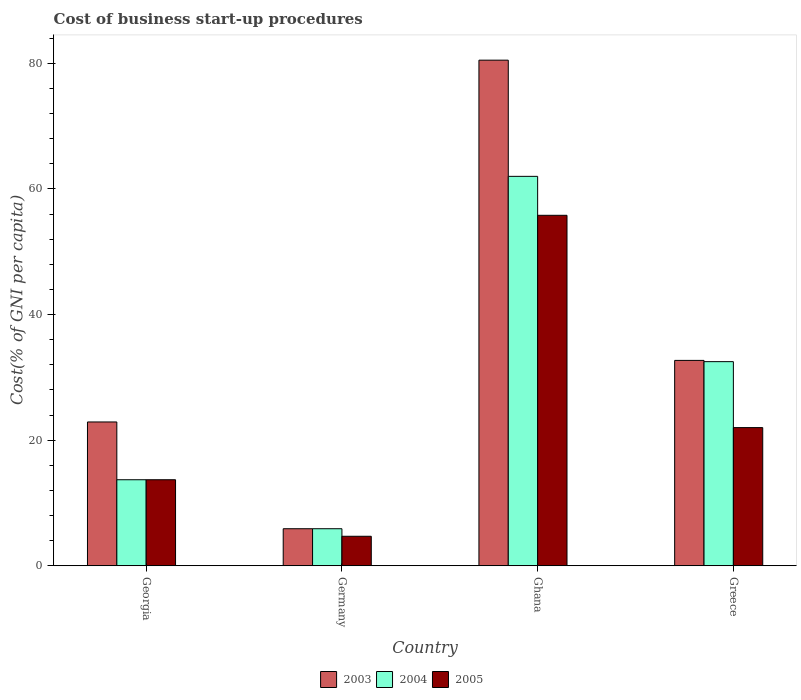How many bars are there on the 4th tick from the right?
Offer a terse response. 3. What is the label of the 3rd group of bars from the left?
Your answer should be compact. Ghana. What is the cost of business start-up procedures in 2003 in Ghana?
Offer a very short reply. 80.5. Across all countries, what is the maximum cost of business start-up procedures in 2005?
Your answer should be very brief. 55.8. Across all countries, what is the minimum cost of business start-up procedures in 2005?
Provide a succinct answer. 4.7. In which country was the cost of business start-up procedures in 2003 maximum?
Your answer should be compact. Ghana. What is the total cost of business start-up procedures in 2005 in the graph?
Make the answer very short. 96.2. What is the difference between the cost of business start-up procedures in 2004 in Germany and that in Greece?
Your answer should be compact. -26.6. What is the difference between the cost of business start-up procedures in 2004 in Georgia and the cost of business start-up procedures in 2003 in Germany?
Keep it short and to the point. 7.8. What is the average cost of business start-up procedures in 2003 per country?
Give a very brief answer. 35.5. What is the difference between the cost of business start-up procedures of/in 2004 and cost of business start-up procedures of/in 2003 in Germany?
Provide a succinct answer. 0. What is the ratio of the cost of business start-up procedures in 2005 in Ghana to that in Greece?
Provide a succinct answer. 2.54. Is the cost of business start-up procedures in 2004 in Georgia less than that in Greece?
Your answer should be very brief. Yes. What is the difference between the highest and the lowest cost of business start-up procedures in 2003?
Your answer should be compact. 74.6. In how many countries, is the cost of business start-up procedures in 2003 greater than the average cost of business start-up procedures in 2003 taken over all countries?
Make the answer very short. 1. Are all the bars in the graph horizontal?
Offer a very short reply. No. What is the difference between two consecutive major ticks on the Y-axis?
Your answer should be very brief. 20. Are the values on the major ticks of Y-axis written in scientific E-notation?
Provide a succinct answer. No. Does the graph contain any zero values?
Ensure brevity in your answer.  No. Where does the legend appear in the graph?
Give a very brief answer. Bottom center. How are the legend labels stacked?
Your answer should be compact. Horizontal. What is the title of the graph?
Provide a short and direct response. Cost of business start-up procedures. Does "2009" appear as one of the legend labels in the graph?
Your response must be concise. No. What is the label or title of the X-axis?
Offer a terse response. Country. What is the label or title of the Y-axis?
Provide a succinct answer. Cost(% of GNI per capita). What is the Cost(% of GNI per capita) of 2003 in Georgia?
Your answer should be very brief. 22.9. What is the Cost(% of GNI per capita) in 2005 in Georgia?
Keep it short and to the point. 13.7. What is the Cost(% of GNI per capita) of 2004 in Germany?
Your response must be concise. 5.9. What is the Cost(% of GNI per capita) in 2003 in Ghana?
Your answer should be compact. 80.5. What is the Cost(% of GNI per capita) in 2004 in Ghana?
Your response must be concise. 62. What is the Cost(% of GNI per capita) in 2005 in Ghana?
Provide a succinct answer. 55.8. What is the Cost(% of GNI per capita) in 2003 in Greece?
Keep it short and to the point. 32.7. What is the Cost(% of GNI per capita) of 2004 in Greece?
Give a very brief answer. 32.5. What is the Cost(% of GNI per capita) of 2005 in Greece?
Provide a succinct answer. 22. Across all countries, what is the maximum Cost(% of GNI per capita) in 2003?
Provide a succinct answer. 80.5. Across all countries, what is the maximum Cost(% of GNI per capita) of 2004?
Offer a very short reply. 62. Across all countries, what is the maximum Cost(% of GNI per capita) of 2005?
Make the answer very short. 55.8. Across all countries, what is the minimum Cost(% of GNI per capita) of 2003?
Provide a short and direct response. 5.9. Across all countries, what is the minimum Cost(% of GNI per capita) of 2004?
Your answer should be very brief. 5.9. Across all countries, what is the minimum Cost(% of GNI per capita) in 2005?
Offer a very short reply. 4.7. What is the total Cost(% of GNI per capita) in 2003 in the graph?
Provide a succinct answer. 142. What is the total Cost(% of GNI per capita) in 2004 in the graph?
Offer a very short reply. 114.1. What is the total Cost(% of GNI per capita) of 2005 in the graph?
Provide a short and direct response. 96.2. What is the difference between the Cost(% of GNI per capita) of 2003 in Georgia and that in Germany?
Your answer should be compact. 17. What is the difference between the Cost(% of GNI per capita) in 2003 in Georgia and that in Ghana?
Make the answer very short. -57.6. What is the difference between the Cost(% of GNI per capita) of 2004 in Georgia and that in Ghana?
Provide a succinct answer. -48.3. What is the difference between the Cost(% of GNI per capita) in 2005 in Georgia and that in Ghana?
Your answer should be very brief. -42.1. What is the difference between the Cost(% of GNI per capita) in 2003 in Georgia and that in Greece?
Make the answer very short. -9.8. What is the difference between the Cost(% of GNI per capita) in 2004 in Georgia and that in Greece?
Ensure brevity in your answer.  -18.8. What is the difference between the Cost(% of GNI per capita) of 2005 in Georgia and that in Greece?
Make the answer very short. -8.3. What is the difference between the Cost(% of GNI per capita) in 2003 in Germany and that in Ghana?
Provide a succinct answer. -74.6. What is the difference between the Cost(% of GNI per capita) of 2004 in Germany and that in Ghana?
Your response must be concise. -56.1. What is the difference between the Cost(% of GNI per capita) in 2005 in Germany and that in Ghana?
Give a very brief answer. -51.1. What is the difference between the Cost(% of GNI per capita) of 2003 in Germany and that in Greece?
Give a very brief answer. -26.8. What is the difference between the Cost(% of GNI per capita) in 2004 in Germany and that in Greece?
Your answer should be very brief. -26.6. What is the difference between the Cost(% of GNI per capita) in 2005 in Germany and that in Greece?
Provide a short and direct response. -17.3. What is the difference between the Cost(% of GNI per capita) of 2003 in Ghana and that in Greece?
Provide a short and direct response. 47.8. What is the difference between the Cost(% of GNI per capita) in 2004 in Ghana and that in Greece?
Provide a short and direct response. 29.5. What is the difference between the Cost(% of GNI per capita) of 2005 in Ghana and that in Greece?
Your response must be concise. 33.8. What is the difference between the Cost(% of GNI per capita) of 2003 in Georgia and the Cost(% of GNI per capita) of 2004 in Germany?
Offer a terse response. 17. What is the difference between the Cost(% of GNI per capita) in 2003 in Georgia and the Cost(% of GNI per capita) in 2005 in Germany?
Your response must be concise. 18.2. What is the difference between the Cost(% of GNI per capita) in 2004 in Georgia and the Cost(% of GNI per capita) in 2005 in Germany?
Offer a very short reply. 9. What is the difference between the Cost(% of GNI per capita) in 2003 in Georgia and the Cost(% of GNI per capita) in 2004 in Ghana?
Your response must be concise. -39.1. What is the difference between the Cost(% of GNI per capita) of 2003 in Georgia and the Cost(% of GNI per capita) of 2005 in Ghana?
Keep it short and to the point. -32.9. What is the difference between the Cost(% of GNI per capita) in 2004 in Georgia and the Cost(% of GNI per capita) in 2005 in Ghana?
Give a very brief answer. -42.1. What is the difference between the Cost(% of GNI per capita) of 2003 in Georgia and the Cost(% of GNI per capita) of 2004 in Greece?
Your answer should be very brief. -9.6. What is the difference between the Cost(% of GNI per capita) in 2003 in Georgia and the Cost(% of GNI per capita) in 2005 in Greece?
Your answer should be very brief. 0.9. What is the difference between the Cost(% of GNI per capita) of 2004 in Georgia and the Cost(% of GNI per capita) of 2005 in Greece?
Offer a very short reply. -8.3. What is the difference between the Cost(% of GNI per capita) in 2003 in Germany and the Cost(% of GNI per capita) in 2004 in Ghana?
Offer a terse response. -56.1. What is the difference between the Cost(% of GNI per capita) in 2003 in Germany and the Cost(% of GNI per capita) in 2005 in Ghana?
Provide a succinct answer. -49.9. What is the difference between the Cost(% of GNI per capita) in 2004 in Germany and the Cost(% of GNI per capita) in 2005 in Ghana?
Give a very brief answer. -49.9. What is the difference between the Cost(% of GNI per capita) in 2003 in Germany and the Cost(% of GNI per capita) in 2004 in Greece?
Provide a short and direct response. -26.6. What is the difference between the Cost(% of GNI per capita) in 2003 in Germany and the Cost(% of GNI per capita) in 2005 in Greece?
Provide a short and direct response. -16.1. What is the difference between the Cost(% of GNI per capita) in 2004 in Germany and the Cost(% of GNI per capita) in 2005 in Greece?
Your answer should be very brief. -16.1. What is the difference between the Cost(% of GNI per capita) of 2003 in Ghana and the Cost(% of GNI per capita) of 2004 in Greece?
Your answer should be very brief. 48. What is the difference between the Cost(% of GNI per capita) of 2003 in Ghana and the Cost(% of GNI per capita) of 2005 in Greece?
Provide a succinct answer. 58.5. What is the difference between the Cost(% of GNI per capita) of 2004 in Ghana and the Cost(% of GNI per capita) of 2005 in Greece?
Give a very brief answer. 40. What is the average Cost(% of GNI per capita) of 2003 per country?
Offer a very short reply. 35.5. What is the average Cost(% of GNI per capita) of 2004 per country?
Provide a short and direct response. 28.52. What is the average Cost(% of GNI per capita) in 2005 per country?
Provide a succinct answer. 24.05. What is the difference between the Cost(% of GNI per capita) in 2003 and Cost(% of GNI per capita) in 2004 in Georgia?
Ensure brevity in your answer.  9.2. What is the difference between the Cost(% of GNI per capita) in 2003 and Cost(% of GNI per capita) in 2005 in Georgia?
Make the answer very short. 9.2. What is the difference between the Cost(% of GNI per capita) of 2004 and Cost(% of GNI per capita) of 2005 in Georgia?
Provide a succinct answer. 0. What is the difference between the Cost(% of GNI per capita) in 2003 and Cost(% of GNI per capita) in 2005 in Ghana?
Your answer should be compact. 24.7. What is the difference between the Cost(% of GNI per capita) of 2004 and Cost(% of GNI per capita) of 2005 in Ghana?
Offer a very short reply. 6.2. What is the ratio of the Cost(% of GNI per capita) of 2003 in Georgia to that in Germany?
Offer a very short reply. 3.88. What is the ratio of the Cost(% of GNI per capita) in 2004 in Georgia to that in Germany?
Make the answer very short. 2.32. What is the ratio of the Cost(% of GNI per capita) in 2005 in Georgia to that in Germany?
Offer a terse response. 2.91. What is the ratio of the Cost(% of GNI per capita) in 2003 in Georgia to that in Ghana?
Offer a very short reply. 0.28. What is the ratio of the Cost(% of GNI per capita) in 2004 in Georgia to that in Ghana?
Keep it short and to the point. 0.22. What is the ratio of the Cost(% of GNI per capita) of 2005 in Georgia to that in Ghana?
Provide a short and direct response. 0.25. What is the ratio of the Cost(% of GNI per capita) of 2003 in Georgia to that in Greece?
Your answer should be very brief. 0.7. What is the ratio of the Cost(% of GNI per capita) in 2004 in Georgia to that in Greece?
Your response must be concise. 0.42. What is the ratio of the Cost(% of GNI per capita) in 2005 in Georgia to that in Greece?
Provide a succinct answer. 0.62. What is the ratio of the Cost(% of GNI per capita) in 2003 in Germany to that in Ghana?
Give a very brief answer. 0.07. What is the ratio of the Cost(% of GNI per capita) of 2004 in Germany to that in Ghana?
Offer a very short reply. 0.1. What is the ratio of the Cost(% of GNI per capita) of 2005 in Germany to that in Ghana?
Offer a very short reply. 0.08. What is the ratio of the Cost(% of GNI per capita) in 2003 in Germany to that in Greece?
Make the answer very short. 0.18. What is the ratio of the Cost(% of GNI per capita) of 2004 in Germany to that in Greece?
Provide a short and direct response. 0.18. What is the ratio of the Cost(% of GNI per capita) in 2005 in Germany to that in Greece?
Make the answer very short. 0.21. What is the ratio of the Cost(% of GNI per capita) in 2003 in Ghana to that in Greece?
Offer a terse response. 2.46. What is the ratio of the Cost(% of GNI per capita) in 2004 in Ghana to that in Greece?
Offer a terse response. 1.91. What is the ratio of the Cost(% of GNI per capita) of 2005 in Ghana to that in Greece?
Offer a very short reply. 2.54. What is the difference between the highest and the second highest Cost(% of GNI per capita) of 2003?
Offer a very short reply. 47.8. What is the difference between the highest and the second highest Cost(% of GNI per capita) of 2004?
Offer a terse response. 29.5. What is the difference between the highest and the second highest Cost(% of GNI per capita) in 2005?
Provide a short and direct response. 33.8. What is the difference between the highest and the lowest Cost(% of GNI per capita) of 2003?
Provide a short and direct response. 74.6. What is the difference between the highest and the lowest Cost(% of GNI per capita) in 2004?
Your answer should be very brief. 56.1. What is the difference between the highest and the lowest Cost(% of GNI per capita) of 2005?
Provide a succinct answer. 51.1. 